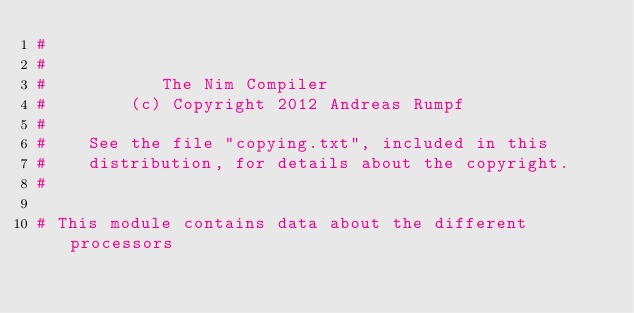Convert code to text. <code><loc_0><loc_0><loc_500><loc_500><_Nim_>#
#
#           The Nim Compiler
#        (c) Copyright 2012 Andreas Rumpf
#
#    See the file "copying.txt", included in this
#    distribution, for details about the copyright.
#

# This module contains data about the different processors</code> 